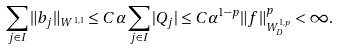<formula> <loc_0><loc_0><loc_500><loc_500>\sum _ { j \in I } \| b _ { j } \| _ { W ^ { 1 , 1 } } \leq C \alpha \sum _ { j \in I } | Q _ { j } | \leq C \alpha ^ { 1 - p } \| f \| _ { W ^ { 1 , p } _ { D } } ^ { p } < \infty .</formula> 